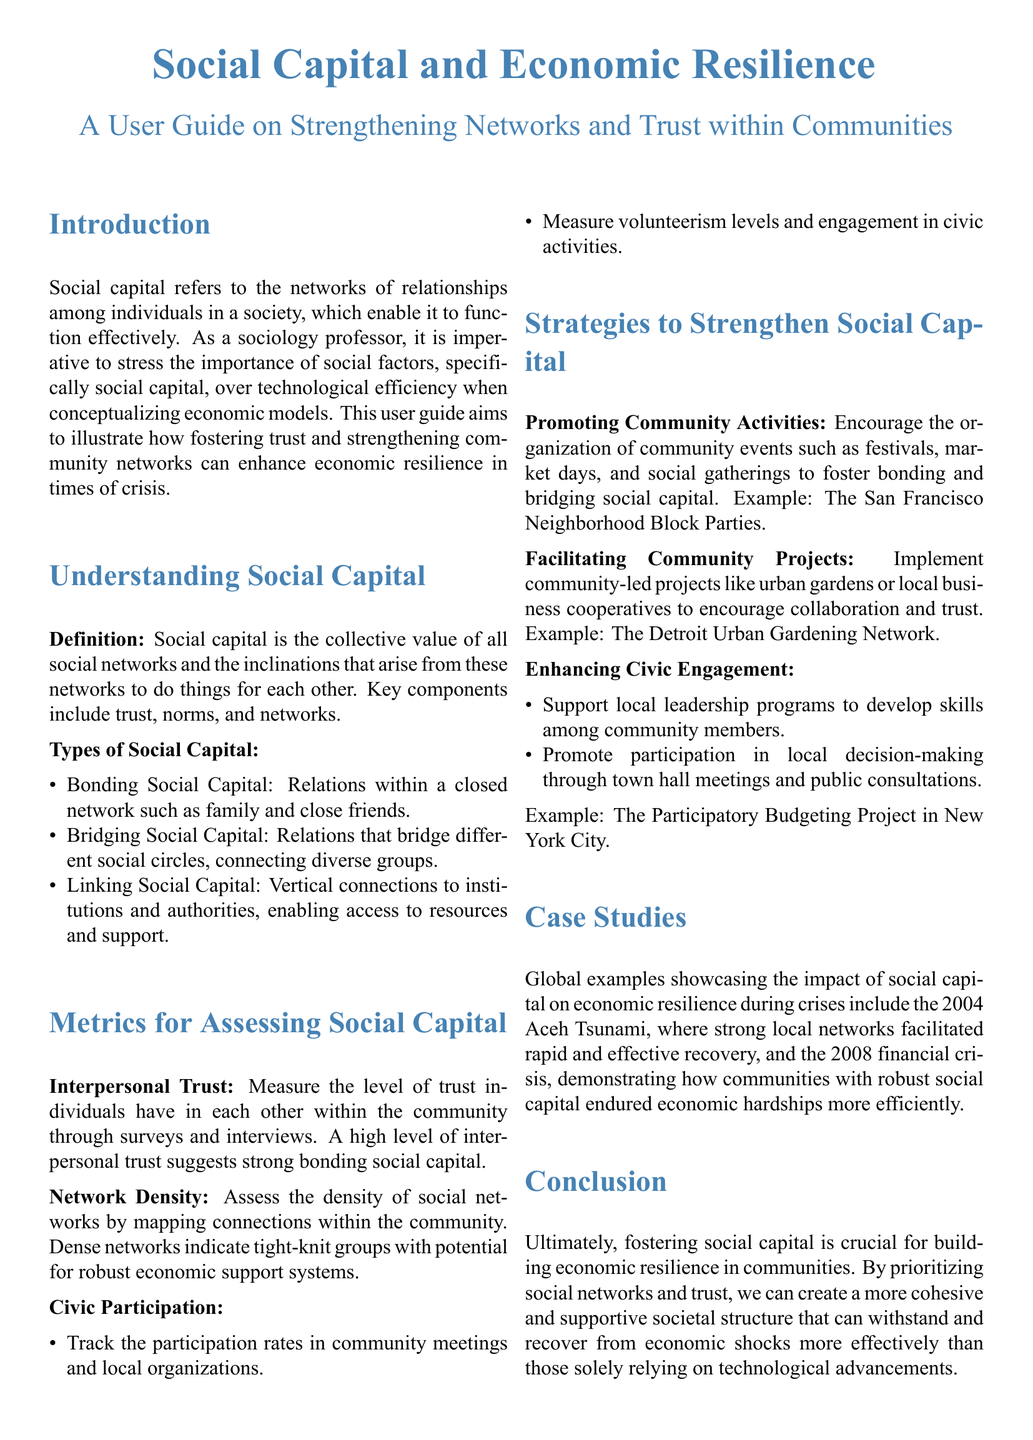what is social capital? Social capital is defined as the collective value of all social networks and the inclinations that arise from these networks to do things for each other.
Answer: collective value of all social networks what are the types of social capital? The document lists three types of social capital, explaining each one briefly.
Answer: Bonding, Bridging, Linking what metric assesses the level of trust among individuals? The document mentions a metric specifically focused on interpersonal feelings within the community.
Answer: Interpersonal Trust name one strategy to strengthen social capital. Various strategies are outlined in the document to enhance social capital, and this is one example provided.
Answer: Promoting Community Activities which case study illustrates social capital's impact during a crisis? A specific global event is mentioned in the document as an example of effective recovery due to local networks.
Answer: 2004 Aceh Tsunami how can civic participation be measured? The document states specific activities to track engagement levels in the community.
Answer: Participation in community meetings what is the main focus of the user guide? The primary goal of the user guide is described in the introduction section summarizing its objective.
Answer: Strengthening Networks and Trust what should be prioritized to build economic resilience according to the conclusion? The conclusion emphasizes the elements that are crucial for enhancing communities' ability to withstand shocks.
Answer: Social networks and trust 